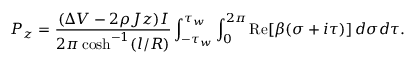Convert formula to latex. <formula><loc_0><loc_0><loc_500><loc_500>P _ { z } = \frac { ( \Delta V - 2 \rho J z ) I } { 2 \pi \cosh ^ { - 1 } ( l / R ) } \int _ { - \tau _ { w } } ^ { \tau _ { w } } \int _ { 0 } ^ { 2 \pi } R e [ \beta ( \sigma + i \tau ) ] \, d \sigma d \tau .</formula> 